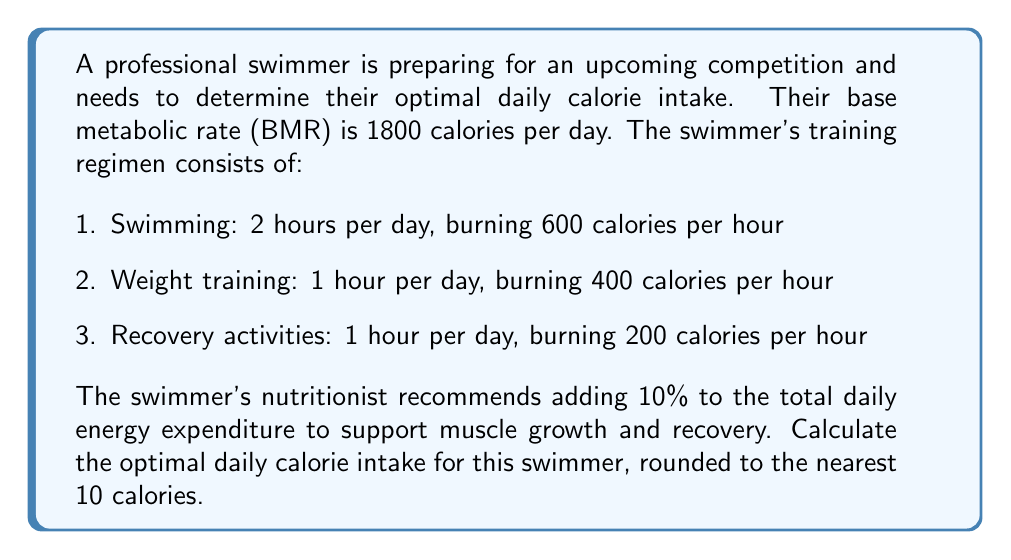Teach me how to tackle this problem. To solve this problem, we'll follow these steps:

1. Calculate the Base Metabolic Rate (BMR):
   BMR = 1800 calories

2. Calculate calories burned during activities:
   Swimming: $2 \text{ hours} \times 600 \text{ calories/hour} = 1200 \text{ calories}$
   Weight training: $1 \text{ hour} \times 400 \text{ calories/hour} = 400 \text{ calories}$
   Recovery activities: $1 \text{ hour} \times 200 \text{ calories/hour} = 200 \text{ calories}$

3. Sum up total calories burned during activities:
   $\text{Total activity calories} = 1200 + 400 + 200 = 1800 \text{ calories}$

4. Calculate total daily energy expenditure (TDEE):
   $\text{TDEE} = \text{BMR} + \text{Total activity calories}$
   $\text{TDEE} = 1800 + 1800 = 3600 \text{ calories}$

5. Add 10% to TDEE for muscle growth and recovery:
   $\text{Optimal calorie intake} = \text{TDEE} \times 1.10$
   $\text{Optimal calorie intake} = 3600 \times 1.10 = 3960 \text{ calories}$

6. Round to the nearest 10 calories:
   $3960 \text{ calories} \approx 3960 \text{ calories}$ (already a multiple of 10)

Therefore, the optimal daily calorie intake for this swimmer is 3960 calories.
Answer: 3960 calories 